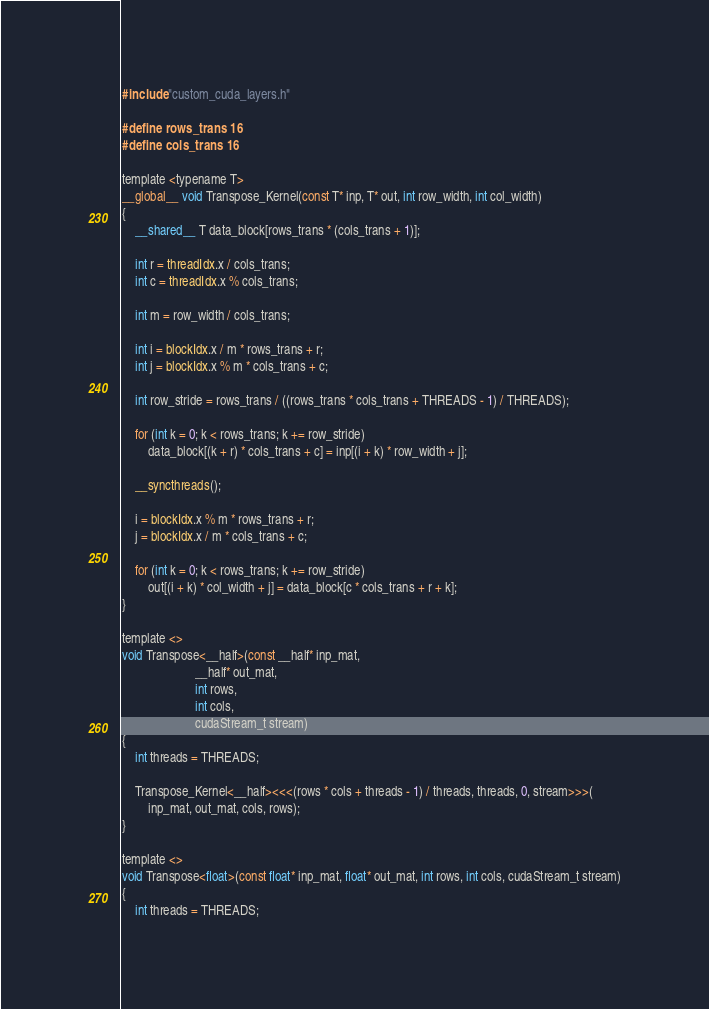<code> <loc_0><loc_0><loc_500><loc_500><_Cuda_>#include "custom_cuda_layers.h"

#define rows_trans 16
#define cols_trans 16

template <typename T>
__global__ void Transpose_Kernel(const T* inp, T* out, int row_width, int col_width)
{
    __shared__ T data_block[rows_trans * (cols_trans + 1)];

    int r = threadIdx.x / cols_trans;
    int c = threadIdx.x % cols_trans;

    int m = row_width / cols_trans;

    int i = blockIdx.x / m * rows_trans + r;
    int j = blockIdx.x % m * cols_trans + c;

    int row_stride = rows_trans / ((rows_trans * cols_trans + THREADS - 1) / THREADS);

    for (int k = 0; k < rows_trans; k += row_stride)
        data_block[(k + r) * cols_trans + c] = inp[(i + k) * row_width + j];

    __syncthreads();

    i = blockIdx.x % m * rows_trans + r;
    j = blockIdx.x / m * cols_trans + c;

    for (int k = 0; k < rows_trans; k += row_stride)
        out[(i + k) * col_width + j] = data_block[c * cols_trans + r + k];
}

template <>
void Transpose<__half>(const __half* inp_mat,
                       __half* out_mat,
                       int rows,
                       int cols,
                       cudaStream_t stream)
{
    int threads = THREADS;

    Transpose_Kernel<__half><<<(rows * cols + threads - 1) / threads, threads, 0, stream>>>(
        inp_mat, out_mat, cols, rows);
}

template <>
void Transpose<float>(const float* inp_mat, float* out_mat, int rows, int cols, cudaStream_t stream)
{
    int threads = THREADS;
</code> 